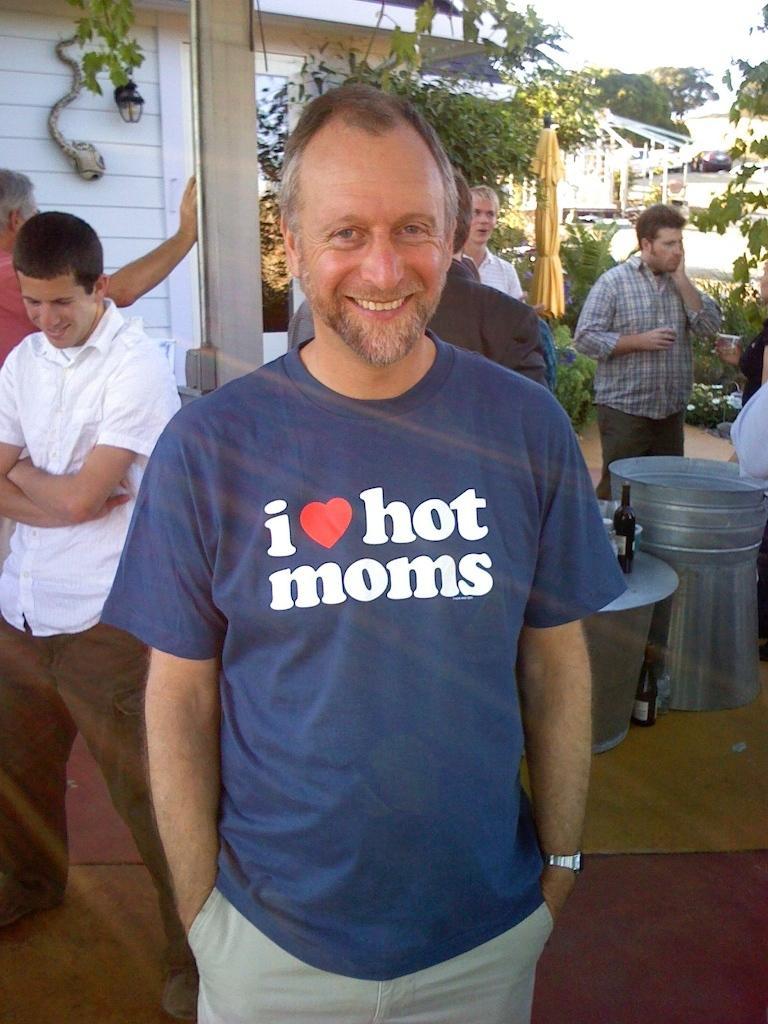Can you describe this image briefly? Here I can see a man wearing a t-shirt, standing, smiling and giving pose for the picture. At the back of this man few more men are standing. On the right side there are few objects and bottles are placed on the ground. In the background there are few houses, trees, plants and also I can see a car on the road. At the top of the image I can see the sky. 